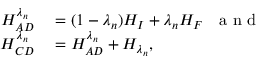Convert formula to latex. <formula><loc_0><loc_0><loc_500><loc_500>\begin{array} { r l } { H _ { A D } ^ { \lambda _ { n } } } & = ( 1 - \lambda _ { n } ) H _ { I } + \lambda _ { n } H _ { F } a n d } \\ { H _ { C D } ^ { \lambda _ { n } } } & = H _ { A D } ^ { \lambda _ { n } } + H _ { \lambda _ { n } } , } \end{array}</formula> 